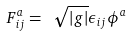<formula> <loc_0><loc_0><loc_500><loc_500>F _ { i j } ^ { a } = \ \sqrt { | g | } \epsilon _ { i j } \phi ^ { a }</formula> 